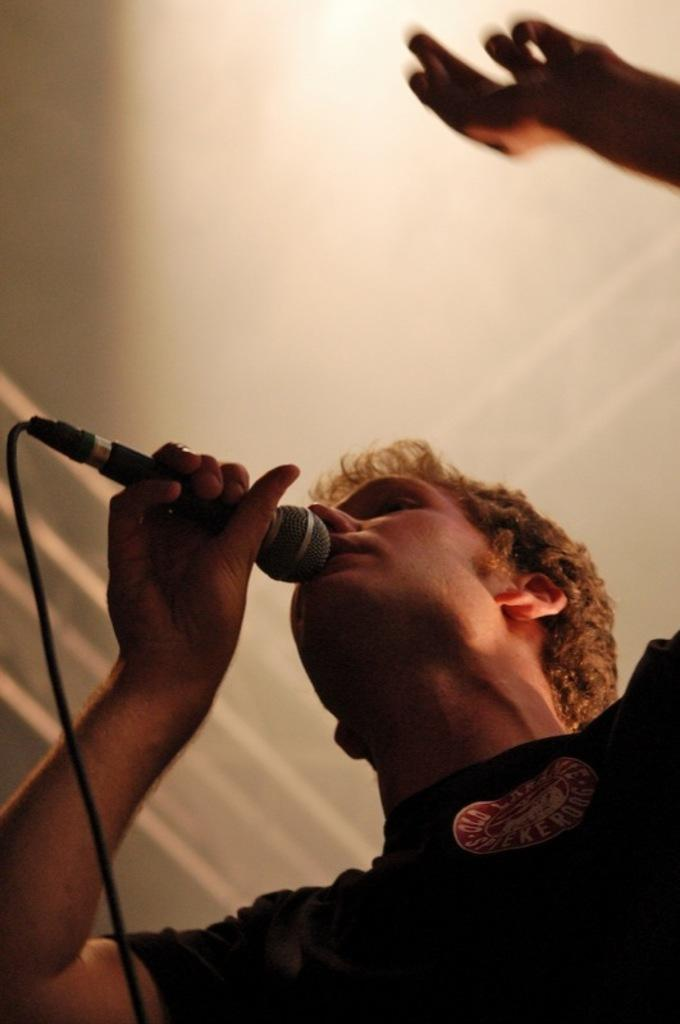Who is the main subject in the image? There is a man in the image. What is the man doing in the image? The man is singing a song in the image. What tool is the man using to amplify his voice? The man is using a microphone in the image. Can you describe the microphone's appearance? The microphone has a wire attached to it in the image. Can you see any rabbits in the image? There are no rabbits present in the image. What type of grain is being used in the song the man is singing? The image does not depict any grain or mention any lyrics related to grain in the song being sung. 